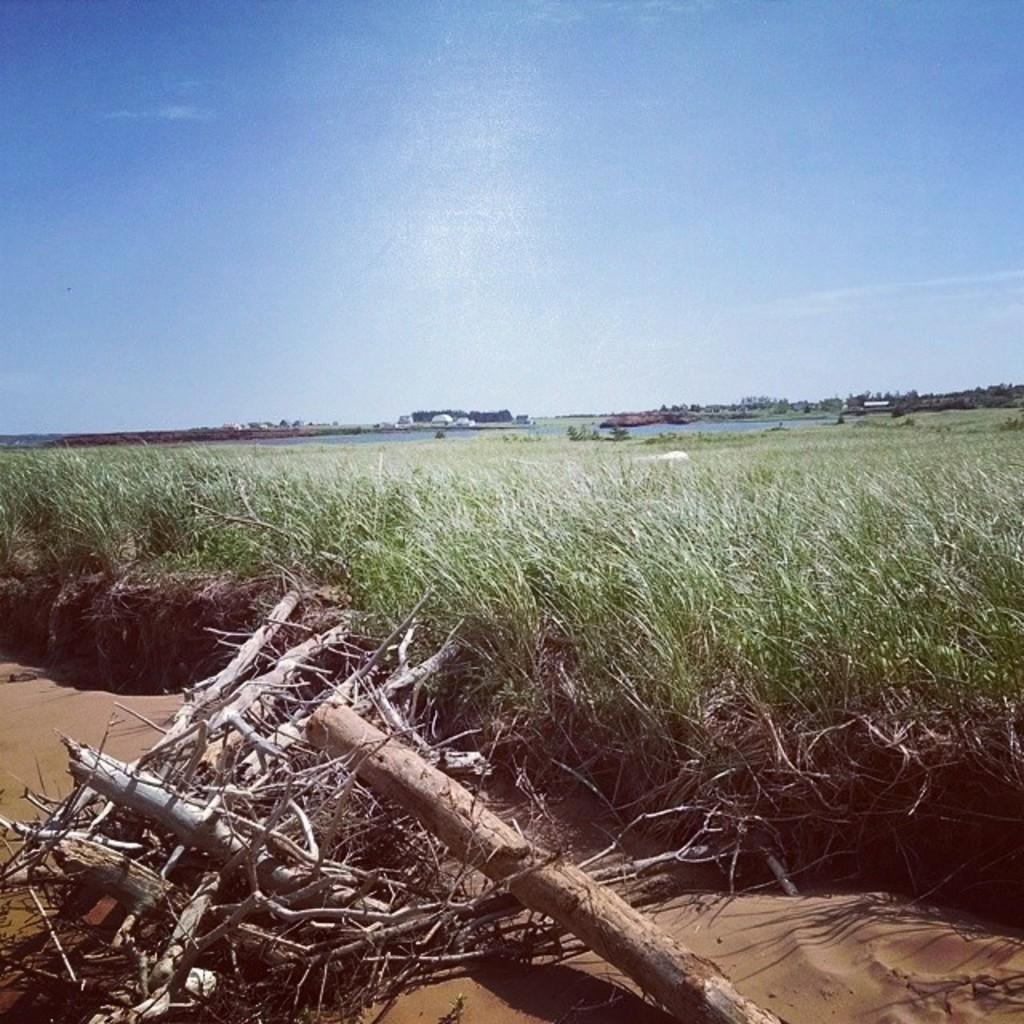What can be seen in the sky in the image? The sky is visible in the image. What type of terrain is present in the image? There is water, grass, and sand visible in the image. What natural object can be seen in the image? There is a log in the image. What man-made objects are present in the image? Wooden sticks are present in the image. What is the baby's tendency when playing with the truck in the image? There is no baby or truck present in the image, so this question cannot be answered. 